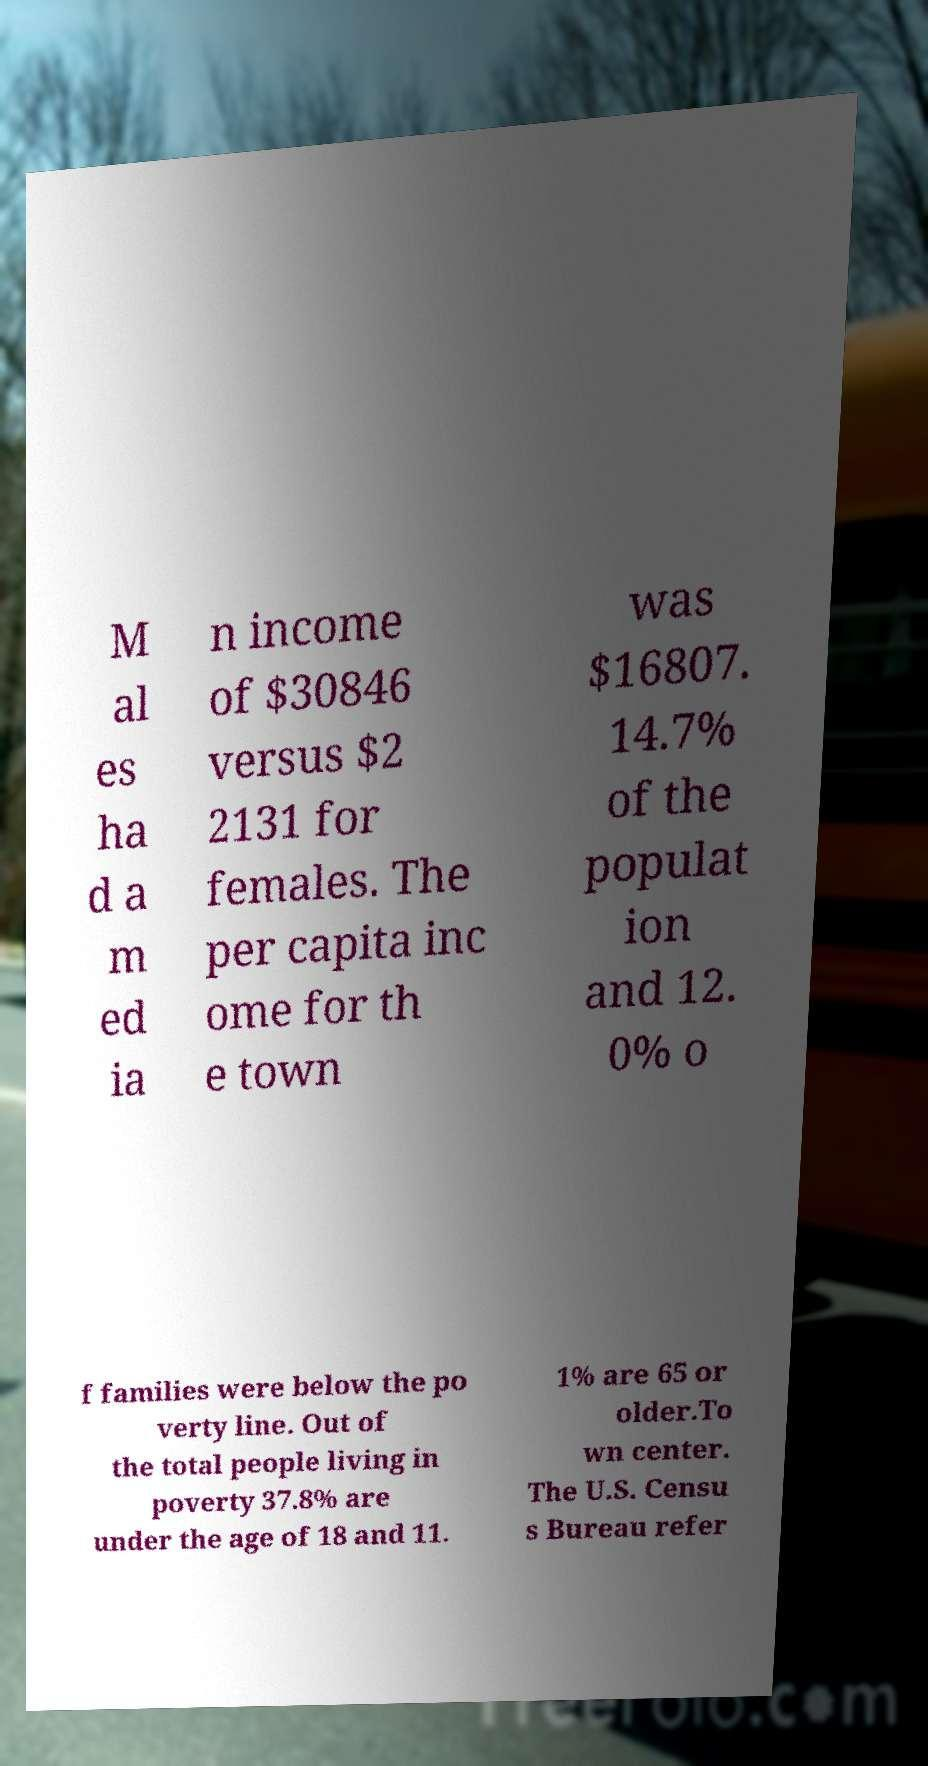I need the written content from this picture converted into text. Can you do that? M al es ha d a m ed ia n income of $30846 versus $2 2131 for females. The per capita inc ome for th e town was $16807. 14.7% of the populat ion and 12. 0% o f families were below the po verty line. Out of the total people living in poverty 37.8% are under the age of 18 and 11. 1% are 65 or older.To wn center. The U.S. Censu s Bureau refer 